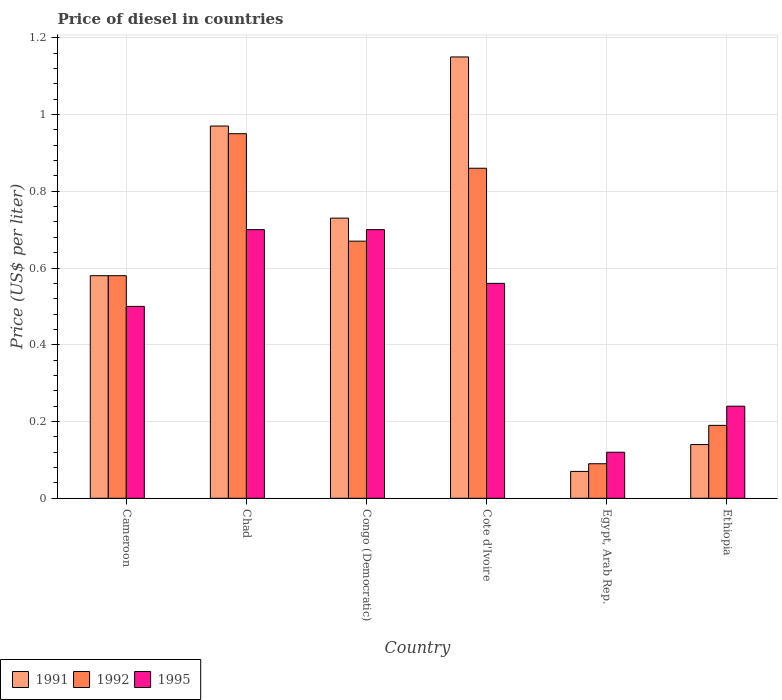How many different coloured bars are there?
Offer a terse response. 3. Are the number of bars on each tick of the X-axis equal?
Your answer should be very brief. Yes. How many bars are there on the 3rd tick from the left?
Give a very brief answer. 3. What is the label of the 1st group of bars from the left?
Keep it short and to the point. Cameroon. In how many cases, is the number of bars for a given country not equal to the number of legend labels?
Offer a terse response. 0. What is the price of diesel in 1992 in Chad?
Make the answer very short. 0.95. Across all countries, what is the maximum price of diesel in 1995?
Provide a short and direct response. 0.7. Across all countries, what is the minimum price of diesel in 1991?
Your answer should be compact. 0.07. In which country was the price of diesel in 1992 maximum?
Keep it short and to the point. Chad. In which country was the price of diesel in 1992 minimum?
Provide a succinct answer. Egypt, Arab Rep. What is the total price of diesel in 1995 in the graph?
Your answer should be compact. 2.82. What is the difference between the price of diesel in 1991 in Cameroon and that in Egypt, Arab Rep.?
Offer a very short reply. 0.51. What is the difference between the price of diesel in 1991 in Ethiopia and the price of diesel in 1995 in Egypt, Arab Rep.?
Offer a very short reply. 0.02. What is the average price of diesel in 1992 per country?
Ensure brevity in your answer.  0.56. What is the difference between the price of diesel of/in 1991 and price of diesel of/in 1995 in Ethiopia?
Offer a very short reply. -0.1. What is the ratio of the price of diesel in 1991 in Congo (Democratic) to that in Egypt, Arab Rep.?
Offer a terse response. 10.43. Is the price of diesel in 1995 in Congo (Democratic) less than that in Ethiopia?
Keep it short and to the point. No. What is the difference between the highest and the second highest price of diesel in 1992?
Your response must be concise. 0.09. What is the difference between the highest and the lowest price of diesel in 1995?
Give a very brief answer. 0.58. In how many countries, is the price of diesel in 1992 greater than the average price of diesel in 1992 taken over all countries?
Your response must be concise. 4. Is the sum of the price of diesel in 1992 in Chad and Congo (Democratic) greater than the maximum price of diesel in 1995 across all countries?
Your answer should be compact. Yes. Is it the case that in every country, the sum of the price of diesel in 1992 and price of diesel in 1991 is greater than the price of diesel in 1995?
Give a very brief answer. Yes. How many countries are there in the graph?
Keep it short and to the point. 6. What is the difference between two consecutive major ticks on the Y-axis?
Provide a short and direct response. 0.2. Does the graph contain any zero values?
Ensure brevity in your answer.  No. Does the graph contain grids?
Your answer should be compact. Yes. How are the legend labels stacked?
Give a very brief answer. Horizontal. What is the title of the graph?
Ensure brevity in your answer.  Price of diesel in countries. What is the label or title of the Y-axis?
Your response must be concise. Price (US$ per liter). What is the Price (US$ per liter) in 1991 in Cameroon?
Your answer should be compact. 0.58. What is the Price (US$ per liter) of 1992 in Cameroon?
Give a very brief answer. 0.58. What is the Price (US$ per liter) of 1995 in Chad?
Ensure brevity in your answer.  0.7. What is the Price (US$ per liter) in 1991 in Congo (Democratic)?
Your answer should be compact. 0.73. What is the Price (US$ per liter) of 1992 in Congo (Democratic)?
Your response must be concise. 0.67. What is the Price (US$ per liter) of 1995 in Congo (Democratic)?
Keep it short and to the point. 0.7. What is the Price (US$ per liter) of 1991 in Cote d'Ivoire?
Give a very brief answer. 1.15. What is the Price (US$ per liter) of 1992 in Cote d'Ivoire?
Give a very brief answer. 0.86. What is the Price (US$ per liter) of 1995 in Cote d'Ivoire?
Your answer should be very brief. 0.56. What is the Price (US$ per liter) of 1991 in Egypt, Arab Rep.?
Keep it short and to the point. 0.07. What is the Price (US$ per liter) of 1992 in Egypt, Arab Rep.?
Keep it short and to the point. 0.09. What is the Price (US$ per liter) in 1995 in Egypt, Arab Rep.?
Keep it short and to the point. 0.12. What is the Price (US$ per liter) of 1991 in Ethiopia?
Make the answer very short. 0.14. What is the Price (US$ per liter) of 1992 in Ethiopia?
Keep it short and to the point. 0.19. What is the Price (US$ per liter) in 1995 in Ethiopia?
Give a very brief answer. 0.24. Across all countries, what is the maximum Price (US$ per liter) in 1991?
Provide a succinct answer. 1.15. Across all countries, what is the maximum Price (US$ per liter) of 1992?
Make the answer very short. 0.95. Across all countries, what is the minimum Price (US$ per liter) in 1991?
Give a very brief answer. 0.07. Across all countries, what is the minimum Price (US$ per liter) in 1992?
Ensure brevity in your answer.  0.09. Across all countries, what is the minimum Price (US$ per liter) of 1995?
Provide a short and direct response. 0.12. What is the total Price (US$ per liter) of 1991 in the graph?
Your response must be concise. 3.64. What is the total Price (US$ per liter) in 1992 in the graph?
Offer a very short reply. 3.34. What is the total Price (US$ per liter) of 1995 in the graph?
Your response must be concise. 2.82. What is the difference between the Price (US$ per liter) of 1991 in Cameroon and that in Chad?
Your answer should be compact. -0.39. What is the difference between the Price (US$ per liter) of 1992 in Cameroon and that in Chad?
Your response must be concise. -0.37. What is the difference between the Price (US$ per liter) of 1995 in Cameroon and that in Chad?
Offer a very short reply. -0.2. What is the difference between the Price (US$ per liter) in 1991 in Cameroon and that in Congo (Democratic)?
Give a very brief answer. -0.15. What is the difference between the Price (US$ per liter) of 1992 in Cameroon and that in Congo (Democratic)?
Your response must be concise. -0.09. What is the difference between the Price (US$ per liter) in 1991 in Cameroon and that in Cote d'Ivoire?
Offer a terse response. -0.57. What is the difference between the Price (US$ per liter) of 1992 in Cameroon and that in Cote d'Ivoire?
Your answer should be very brief. -0.28. What is the difference between the Price (US$ per liter) in 1995 in Cameroon and that in Cote d'Ivoire?
Your answer should be very brief. -0.06. What is the difference between the Price (US$ per liter) in 1991 in Cameroon and that in Egypt, Arab Rep.?
Offer a very short reply. 0.51. What is the difference between the Price (US$ per liter) in 1992 in Cameroon and that in Egypt, Arab Rep.?
Offer a very short reply. 0.49. What is the difference between the Price (US$ per liter) of 1995 in Cameroon and that in Egypt, Arab Rep.?
Give a very brief answer. 0.38. What is the difference between the Price (US$ per liter) of 1991 in Cameroon and that in Ethiopia?
Provide a succinct answer. 0.44. What is the difference between the Price (US$ per liter) of 1992 in Cameroon and that in Ethiopia?
Your response must be concise. 0.39. What is the difference between the Price (US$ per liter) of 1995 in Cameroon and that in Ethiopia?
Offer a terse response. 0.26. What is the difference between the Price (US$ per liter) in 1991 in Chad and that in Congo (Democratic)?
Your answer should be compact. 0.24. What is the difference between the Price (US$ per liter) of 1992 in Chad and that in Congo (Democratic)?
Keep it short and to the point. 0.28. What is the difference between the Price (US$ per liter) in 1995 in Chad and that in Congo (Democratic)?
Keep it short and to the point. 0. What is the difference between the Price (US$ per liter) of 1991 in Chad and that in Cote d'Ivoire?
Give a very brief answer. -0.18. What is the difference between the Price (US$ per liter) in 1992 in Chad and that in Cote d'Ivoire?
Give a very brief answer. 0.09. What is the difference between the Price (US$ per liter) in 1995 in Chad and that in Cote d'Ivoire?
Your answer should be very brief. 0.14. What is the difference between the Price (US$ per liter) in 1991 in Chad and that in Egypt, Arab Rep.?
Offer a very short reply. 0.9. What is the difference between the Price (US$ per liter) of 1992 in Chad and that in Egypt, Arab Rep.?
Ensure brevity in your answer.  0.86. What is the difference between the Price (US$ per liter) in 1995 in Chad and that in Egypt, Arab Rep.?
Make the answer very short. 0.58. What is the difference between the Price (US$ per liter) in 1991 in Chad and that in Ethiopia?
Keep it short and to the point. 0.83. What is the difference between the Price (US$ per liter) in 1992 in Chad and that in Ethiopia?
Your answer should be very brief. 0.76. What is the difference between the Price (US$ per liter) in 1995 in Chad and that in Ethiopia?
Offer a terse response. 0.46. What is the difference between the Price (US$ per liter) in 1991 in Congo (Democratic) and that in Cote d'Ivoire?
Offer a terse response. -0.42. What is the difference between the Price (US$ per liter) in 1992 in Congo (Democratic) and that in Cote d'Ivoire?
Offer a terse response. -0.19. What is the difference between the Price (US$ per liter) in 1995 in Congo (Democratic) and that in Cote d'Ivoire?
Keep it short and to the point. 0.14. What is the difference between the Price (US$ per liter) of 1991 in Congo (Democratic) and that in Egypt, Arab Rep.?
Provide a short and direct response. 0.66. What is the difference between the Price (US$ per liter) in 1992 in Congo (Democratic) and that in Egypt, Arab Rep.?
Offer a very short reply. 0.58. What is the difference between the Price (US$ per liter) in 1995 in Congo (Democratic) and that in Egypt, Arab Rep.?
Your response must be concise. 0.58. What is the difference between the Price (US$ per liter) in 1991 in Congo (Democratic) and that in Ethiopia?
Ensure brevity in your answer.  0.59. What is the difference between the Price (US$ per liter) in 1992 in Congo (Democratic) and that in Ethiopia?
Offer a terse response. 0.48. What is the difference between the Price (US$ per liter) of 1995 in Congo (Democratic) and that in Ethiopia?
Keep it short and to the point. 0.46. What is the difference between the Price (US$ per liter) of 1992 in Cote d'Ivoire and that in Egypt, Arab Rep.?
Your answer should be very brief. 0.77. What is the difference between the Price (US$ per liter) in 1995 in Cote d'Ivoire and that in Egypt, Arab Rep.?
Your answer should be very brief. 0.44. What is the difference between the Price (US$ per liter) of 1991 in Cote d'Ivoire and that in Ethiopia?
Your answer should be very brief. 1.01. What is the difference between the Price (US$ per liter) in 1992 in Cote d'Ivoire and that in Ethiopia?
Offer a very short reply. 0.67. What is the difference between the Price (US$ per liter) in 1995 in Cote d'Ivoire and that in Ethiopia?
Ensure brevity in your answer.  0.32. What is the difference between the Price (US$ per liter) of 1991 in Egypt, Arab Rep. and that in Ethiopia?
Offer a very short reply. -0.07. What is the difference between the Price (US$ per liter) in 1992 in Egypt, Arab Rep. and that in Ethiopia?
Offer a terse response. -0.1. What is the difference between the Price (US$ per liter) in 1995 in Egypt, Arab Rep. and that in Ethiopia?
Give a very brief answer. -0.12. What is the difference between the Price (US$ per liter) of 1991 in Cameroon and the Price (US$ per liter) of 1992 in Chad?
Offer a very short reply. -0.37. What is the difference between the Price (US$ per liter) of 1991 in Cameroon and the Price (US$ per liter) of 1995 in Chad?
Your response must be concise. -0.12. What is the difference between the Price (US$ per liter) of 1992 in Cameroon and the Price (US$ per liter) of 1995 in Chad?
Provide a succinct answer. -0.12. What is the difference between the Price (US$ per liter) in 1991 in Cameroon and the Price (US$ per liter) in 1992 in Congo (Democratic)?
Your answer should be very brief. -0.09. What is the difference between the Price (US$ per liter) of 1991 in Cameroon and the Price (US$ per liter) of 1995 in Congo (Democratic)?
Your response must be concise. -0.12. What is the difference between the Price (US$ per liter) of 1992 in Cameroon and the Price (US$ per liter) of 1995 in Congo (Democratic)?
Provide a short and direct response. -0.12. What is the difference between the Price (US$ per liter) in 1991 in Cameroon and the Price (US$ per liter) in 1992 in Cote d'Ivoire?
Make the answer very short. -0.28. What is the difference between the Price (US$ per liter) of 1991 in Cameroon and the Price (US$ per liter) of 1995 in Cote d'Ivoire?
Provide a short and direct response. 0.02. What is the difference between the Price (US$ per liter) of 1991 in Cameroon and the Price (US$ per liter) of 1992 in Egypt, Arab Rep.?
Keep it short and to the point. 0.49. What is the difference between the Price (US$ per liter) of 1991 in Cameroon and the Price (US$ per liter) of 1995 in Egypt, Arab Rep.?
Provide a succinct answer. 0.46. What is the difference between the Price (US$ per liter) in 1992 in Cameroon and the Price (US$ per liter) in 1995 in Egypt, Arab Rep.?
Make the answer very short. 0.46. What is the difference between the Price (US$ per liter) in 1991 in Cameroon and the Price (US$ per liter) in 1992 in Ethiopia?
Your response must be concise. 0.39. What is the difference between the Price (US$ per liter) of 1991 in Cameroon and the Price (US$ per liter) of 1995 in Ethiopia?
Your answer should be very brief. 0.34. What is the difference between the Price (US$ per liter) in 1992 in Cameroon and the Price (US$ per liter) in 1995 in Ethiopia?
Your answer should be compact. 0.34. What is the difference between the Price (US$ per liter) in 1991 in Chad and the Price (US$ per liter) in 1992 in Congo (Democratic)?
Your response must be concise. 0.3. What is the difference between the Price (US$ per liter) of 1991 in Chad and the Price (US$ per liter) of 1995 in Congo (Democratic)?
Offer a terse response. 0.27. What is the difference between the Price (US$ per liter) of 1991 in Chad and the Price (US$ per liter) of 1992 in Cote d'Ivoire?
Keep it short and to the point. 0.11. What is the difference between the Price (US$ per liter) in 1991 in Chad and the Price (US$ per liter) in 1995 in Cote d'Ivoire?
Your answer should be compact. 0.41. What is the difference between the Price (US$ per liter) in 1992 in Chad and the Price (US$ per liter) in 1995 in Cote d'Ivoire?
Offer a very short reply. 0.39. What is the difference between the Price (US$ per liter) in 1991 in Chad and the Price (US$ per liter) in 1992 in Egypt, Arab Rep.?
Your response must be concise. 0.88. What is the difference between the Price (US$ per liter) in 1992 in Chad and the Price (US$ per liter) in 1995 in Egypt, Arab Rep.?
Offer a very short reply. 0.83. What is the difference between the Price (US$ per liter) of 1991 in Chad and the Price (US$ per liter) of 1992 in Ethiopia?
Offer a terse response. 0.78. What is the difference between the Price (US$ per liter) in 1991 in Chad and the Price (US$ per liter) in 1995 in Ethiopia?
Keep it short and to the point. 0.73. What is the difference between the Price (US$ per liter) in 1992 in Chad and the Price (US$ per liter) in 1995 in Ethiopia?
Make the answer very short. 0.71. What is the difference between the Price (US$ per liter) in 1991 in Congo (Democratic) and the Price (US$ per liter) in 1992 in Cote d'Ivoire?
Ensure brevity in your answer.  -0.13. What is the difference between the Price (US$ per liter) in 1991 in Congo (Democratic) and the Price (US$ per liter) in 1995 in Cote d'Ivoire?
Provide a succinct answer. 0.17. What is the difference between the Price (US$ per liter) of 1992 in Congo (Democratic) and the Price (US$ per liter) of 1995 in Cote d'Ivoire?
Offer a very short reply. 0.11. What is the difference between the Price (US$ per liter) in 1991 in Congo (Democratic) and the Price (US$ per liter) in 1992 in Egypt, Arab Rep.?
Your response must be concise. 0.64. What is the difference between the Price (US$ per liter) in 1991 in Congo (Democratic) and the Price (US$ per liter) in 1995 in Egypt, Arab Rep.?
Offer a terse response. 0.61. What is the difference between the Price (US$ per liter) in 1992 in Congo (Democratic) and the Price (US$ per liter) in 1995 in Egypt, Arab Rep.?
Provide a short and direct response. 0.55. What is the difference between the Price (US$ per liter) in 1991 in Congo (Democratic) and the Price (US$ per liter) in 1992 in Ethiopia?
Your answer should be compact. 0.54. What is the difference between the Price (US$ per liter) in 1991 in Congo (Democratic) and the Price (US$ per liter) in 1995 in Ethiopia?
Keep it short and to the point. 0.49. What is the difference between the Price (US$ per liter) of 1992 in Congo (Democratic) and the Price (US$ per liter) of 1995 in Ethiopia?
Your answer should be compact. 0.43. What is the difference between the Price (US$ per liter) in 1991 in Cote d'Ivoire and the Price (US$ per liter) in 1992 in Egypt, Arab Rep.?
Your answer should be very brief. 1.06. What is the difference between the Price (US$ per liter) in 1992 in Cote d'Ivoire and the Price (US$ per liter) in 1995 in Egypt, Arab Rep.?
Your answer should be compact. 0.74. What is the difference between the Price (US$ per liter) in 1991 in Cote d'Ivoire and the Price (US$ per liter) in 1995 in Ethiopia?
Give a very brief answer. 0.91. What is the difference between the Price (US$ per liter) of 1992 in Cote d'Ivoire and the Price (US$ per liter) of 1995 in Ethiopia?
Offer a very short reply. 0.62. What is the difference between the Price (US$ per liter) of 1991 in Egypt, Arab Rep. and the Price (US$ per liter) of 1992 in Ethiopia?
Ensure brevity in your answer.  -0.12. What is the difference between the Price (US$ per liter) in 1991 in Egypt, Arab Rep. and the Price (US$ per liter) in 1995 in Ethiopia?
Keep it short and to the point. -0.17. What is the average Price (US$ per liter) of 1991 per country?
Give a very brief answer. 0.61. What is the average Price (US$ per liter) in 1992 per country?
Offer a terse response. 0.56. What is the average Price (US$ per liter) of 1995 per country?
Provide a succinct answer. 0.47. What is the difference between the Price (US$ per liter) in 1991 and Price (US$ per liter) in 1992 in Cameroon?
Your answer should be compact. 0. What is the difference between the Price (US$ per liter) of 1991 and Price (US$ per liter) of 1995 in Cameroon?
Provide a short and direct response. 0.08. What is the difference between the Price (US$ per liter) of 1991 and Price (US$ per liter) of 1995 in Chad?
Provide a succinct answer. 0.27. What is the difference between the Price (US$ per liter) of 1992 and Price (US$ per liter) of 1995 in Chad?
Make the answer very short. 0.25. What is the difference between the Price (US$ per liter) of 1991 and Price (US$ per liter) of 1995 in Congo (Democratic)?
Provide a succinct answer. 0.03. What is the difference between the Price (US$ per liter) in 1992 and Price (US$ per liter) in 1995 in Congo (Democratic)?
Give a very brief answer. -0.03. What is the difference between the Price (US$ per liter) of 1991 and Price (US$ per liter) of 1992 in Cote d'Ivoire?
Offer a terse response. 0.29. What is the difference between the Price (US$ per liter) of 1991 and Price (US$ per liter) of 1995 in Cote d'Ivoire?
Keep it short and to the point. 0.59. What is the difference between the Price (US$ per liter) of 1991 and Price (US$ per liter) of 1992 in Egypt, Arab Rep.?
Provide a short and direct response. -0.02. What is the difference between the Price (US$ per liter) of 1991 and Price (US$ per liter) of 1995 in Egypt, Arab Rep.?
Keep it short and to the point. -0.05. What is the difference between the Price (US$ per liter) in 1992 and Price (US$ per liter) in 1995 in Egypt, Arab Rep.?
Your answer should be compact. -0.03. What is the difference between the Price (US$ per liter) in 1991 and Price (US$ per liter) in 1992 in Ethiopia?
Provide a succinct answer. -0.05. What is the difference between the Price (US$ per liter) in 1991 and Price (US$ per liter) in 1995 in Ethiopia?
Keep it short and to the point. -0.1. What is the difference between the Price (US$ per liter) of 1992 and Price (US$ per liter) of 1995 in Ethiopia?
Your answer should be compact. -0.05. What is the ratio of the Price (US$ per liter) in 1991 in Cameroon to that in Chad?
Provide a short and direct response. 0.6. What is the ratio of the Price (US$ per liter) in 1992 in Cameroon to that in Chad?
Your response must be concise. 0.61. What is the ratio of the Price (US$ per liter) of 1991 in Cameroon to that in Congo (Democratic)?
Your answer should be very brief. 0.79. What is the ratio of the Price (US$ per liter) in 1992 in Cameroon to that in Congo (Democratic)?
Offer a very short reply. 0.87. What is the ratio of the Price (US$ per liter) in 1991 in Cameroon to that in Cote d'Ivoire?
Keep it short and to the point. 0.5. What is the ratio of the Price (US$ per liter) in 1992 in Cameroon to that in Cote d'Ivoire?
Ensure brevity in your answer.  0.67. What is the ratio of the Price (US$ per liter) of 1995 in Cameroon to that in Cote d'Ivoire?
Offer a terse response. 0.89. What is the ratio of the Price (US$ per liter) of 1991 in Cameroon to that in Egypt, Arab Rep.?
Keep it short and to the point. 8.29. What is the ratio of the Price (US$ per liter) of 1992 in Cameroon to that in Egypt, Arab Rep.?
Your answer should be very brief. 6.44. What is the ratio of the Price (US$ per liter) in 1995 in Cameroon to that in Egypt, Arab Rep.?
Keep it short and to the point. 4.17. What is the ratio of the Price (US$ per liter) of 1991 in Cameroon to that in Ethiopia?
Give a very brief answer. 4.14. What is the ratio of the Price (US$ per liter) of 1992 in Cameroon to that in Ethiopia?
Your answer should be compact. 3.05. What is the ratio of the Price (US$ per liter) of 1995 in Cameroon to that in Ethiopia?
Offer a terse response. 2.08. What is the ratio of the Price (US$ per liter) of 1991 in Chad to that in Congo (Democratic)?
Your answer should be very brief. 1.33. What is the ratio of the Price (US$ per liter) in 1992 in Chad to that in Congo (Democratic)?
Provide a short and direct response. 1.42. What is the ratio of the Price (US$ per liter) in 1991 in Chad to that in Cote d'Ivoire?
Keep it short and to the point. 0.84. What is the ratio of the Price (US$ per liter) of 1992 in Chad to that in Cote d'Ivoire?
Ensure brevity in your answer.  1.1. What is the ratio of the Price (US$ per liter) of 1995 in Chad to that in Cote d'Ivoire?
Provide a short and direct response. 1.25. What is the ratio of the Price (US$ per liter) in 1991 in Chad to that in Egypt, Arab Rep.?
Your answer should be compact. 13.86. What is the ratio of the Price (US$ per liter) of 1992 in Chad to that in Egypt, Arab Rep.?
Your response must be concise. 10.56. What is the ratio of the Price (US$ per liter) in 1995 in Chad to that in Egypt, Arab Rep.?
Offer a very short reply. 5.83. What is the ratio of the Price (US$ per liter) of 1991 in Chad to that in Ethiopia?
Your answer should be very brief. 6.93. What is the ratio of the Price (US$ per liter) of 1995 in Chad to that in Ethiopia?
Make the answer very short. 2.92. What is the ratio of the Price (US$ per liter) of 1991 in Congo (Democratic) to that in Cote d'Ivoire?
Your answer should be compact. 0.63. What is the ratio of the Price (US$ per liter) in 1992 in Congo (Democratic) to that in Cote d'Ivoire?
Keep it short and to the point. 0.78. What is the ratio of the Price (US$ per liter) of 1995 in Congo (Democratic) to that in Cote d'Ivoire?
Keep it short and to the point. 1.25. What is the ratio of the Price (US$ per liter) of 1991 in Congo (Democratic) to that in Egypt, Arab Rep.?
Offer a terse response. 10.43. What is the ratio of the Price (US$ per liter) in 1992 in Congo (Democratic) to that in Egypt, Arab Rep.?
Offer a terse response. 7.44. What is the ratio of the Price (US$ per liter) of 1995 in Congo (Democratic) to that in Egypt, Arab Rep.?
Offer a very short reply. 5.83. What is the ratio of the Price (US$ per liter) of 1991 in Congo (Democratic) to that in Ethiopia?
Your answer should be very brief. 5.21. What is the ratio of the Price (US$ per liter) of 1992 in Congo (Democratic) to that in Ethiopia?
Offer a very short reply. 3.53. What is the ratio of the Price (US$ per liter) of 1995 in Congo (Democratic) to that in Ethiopia?
Provide a succinct answer. 2.92. What is the ratio of the Price (US$ per liter) of 1991 in Cote d'Ivoire to that in Egypt, Arab Rep.?
Keep it short and to the point. 16.43. What is the ratio of the Price (US$ per liter) in 1992 in Cote d'Ivoire to that in Egypt, Arab Rep.?
Make the answer very short. 9.56. What is the ratio of the Price (US$ per liter) of 1995 in Cote d'Ivoire to that in Egypt, Arab Rep.?
Give a very brief answer. 4.67. What is the ratio of the Price (US$ per liter) of 1991 in Cote d'Ivoire to that in Ethiopia?
Make the answer very short. 8.21. What is the ratio of the Price (US$ per liter) of 1992 in Cote d'Ivoire to that in Ethiopia?
Offer a very short reply. 4.53. What is the ratio of the Price (US$ per liter) in 1995 in Cote d'Ivoire to that in Ethiopia?
Offer a very short reply. 2.33. What is the ratio of the Price (US$ per liter) of 1992 in Egypt, Arab Rep. to that in Ethiopia?
Ensure brevity in your answer.  0.47. What is the ratio of the Price (US$ per liter) in 1995 in Egypt, Arab Rep. to that in Ethiopia?
Give a very brief answer. 0.5. What is the difference between the highest and the second highest Price (US$ per liter) in 1991?
Provide a succinct answer. 0.18. What is the difference between the highest and the second highest Price (US$ per liter) in 1992?
Give a very brief answer. 0.09. What is the difference between the highest and the second highest Price (US$ per liter) in 1995?
Offer a very short reply. 0. What is the difference between the highest and the lowest Price (US$ per liter) of 1991?
Give a very brief answer. 1.08. What is the difference between the highest and the lowest Price (US$ per liter) in 1992?
Your response must be concise. 0.86. What is the difference between the highest and the lowest Price (US$ per liter) in 1995?
Offer a very short reply. 0.58. 